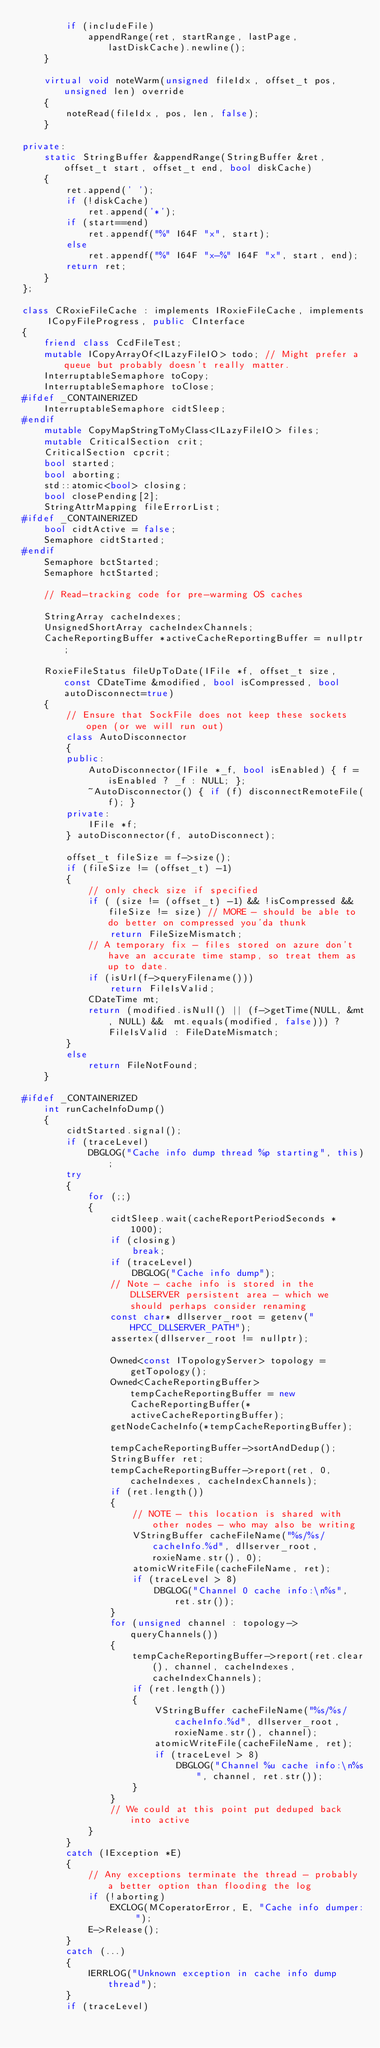<code> <loc_0><loc_0><loc_500><loc_500><_C++_>        if (includeFile)
            appendRange(ret, startRange, lastPage, lastDiskCache).newline();
    }

    virtual void noteWarm(unsigned fileIdx, offset_t pos, unsigned len) override
    {
        noteRead(fileIdx, pos, len, false);
    }

private:
    static StringBuffer &appendRange(StringBuffer &ret, offset_t start, offset_t end, bool diskCache)
    {
        ret.append(' ');
        if (!diskCache)
            ret.append('*');
        if (start==end)
            ret.appendf("%" I64F "x", start);
        else
            ret.appendf("%" I64F "x-%" I64F "x", start, end);
        return ret;
    }
};

class CRoxieFileCache : implements IRoxieFileCache, implements ICopyFileProgress, public CInterface
{
    friend class CcdFileTest;
    mutable ICopyArrayOf<ILazyFileIO> todo; // Might prefer a queue but probably doesn't really matter.
    InterruptableSemaphore toCopy;
    InterruptableSemaphore toClose;
#ifdef _CONTAINERIZED
    InterruptableSemaphore cidtSleep;
#endif
    mutable CopyMapStringToMyClass<ILazyFileIO> files;
    mutable CriticalSection crit;
    CriticalSection cpcrit;
    bool started;
    bool aborting;
    std::atomic<bool> closing;
    bool closePending[2];
    StringAttrMapping fileErrorList;
#ifdef _CONTAINERIZED
    bool cidtActive = false;
    Semaphore cidtStarted;
#endif
    Semaphore bctStarted;
    Semaphore hctStarted;

    // Read-tracking code for pre-warming OS caches

    StringArray cacheIndexes;
    UnsignedShortArray cacheIndexChannels;
    CacheReportingBuffer *activeCacheReportingBuffer = nullptr;

    RoxieFileStatus fileUpToDate(IFile *f, offset_t size, const CDateTime &modified, bool isCompressed, bool autoDisconnect=true)
    {
        // Ensure that SockFile does not keep these sockets open (or we will run out)
        class AutoDisconnector
        {
        public:
            AutoDisconnector(IFile *_f, bool isEnabled) { f = isEnabled ? _f : NULL; };
            ~AutoDisconnector() { if (f) disconnectRemoteFile(f); }
        private:
            IFile *f;
        } autoDisconnector(f, autoDisconnect);

        offset_t fileSize = f->size();
        if (fileSize != (offset_t) -1)
        {
            // only check size if specified
            if ( (size != (offset_t) -1) && !isCompressed && fileSize != size) // MORE - should be able to do better on compressed you'da thunk
                return FileSizeMismatch;
            // A temporary fix - files stored on azure don't have an accurate time stamp, so treat them as up to date.
            if (isUrl(f->queryFilename()))
                return FileIsValid;
            CDateTime mt;
            return (modified.isNull() || (f->getTime(NULL, &mt, NULL) &&  mt.equals(modified, false))) ? FileIsValid : FileDateMismatch;
        }
        else
            return FileNotFound;
    }

#ifdef _CONTAINERIZED
    int runCacheInfoDump()
    {
        cidtStarted.signal();
        if (traceLevel)
            DBGLOG("Cache info dump thread %p starting", this);
        try
        {
            for (;;)
            {
                cidtSleep.wait(cacheReportPeriodSeconds * 1000);
                if (closing)
                    break;
                if (traceLevel)
                    DBGLOG("Cache info dump");
                // Note - cache info is stored in the DLLSERVER persistent area - which we should perhaps consider renaming
                const char* dllserver_root = getenv("HPCC_DLLSERVER_PATH");
                assertex(dllserver_root != nullptr);

                Owned<const ITopologyServer> topology = getTopology();
                Owned<CacheReportingBuffer> tempCacheReportingBuffer = new CacheReportingBuffer(*activeCacheReportingBuffer);
                getNodeCacheInfo(*tempCacheReportingBuffer);

                tempCacheReportingBuffer->sortAndDedup();
                StringBuffer ret;
                tempCacheReportingBuffer->report(ret, 0, cacheIndexes, cacheIndexChannels);
                if (ret.length())
                {
                    // NOTE - this location is shared with other nodes - who may also be writing
                    VStringBuffer cacheFileName("%s/%s/cacheInfo.%d", dllserver_root, roxieName.str(), 0);
                    atomicWriteFile(cacheFileName, ret);
                    if (traceLevel > 8)
                        DBGLOG("Channel 0 cache info:\n%s", ret.str());
                }
                for (unsigned channel : topology->queryChannels())
                {
                    tempCacheReportingBuffer->report(ret.clear(), channel, cacheIndexes, cacheIndexChannels);
                    if (ret.length())
                    {
                        VStringBuffer cacheFileName("%s/%s/cacheInfo.%d", dllserver_root, roxieName.str(), channel);
                        atomicWriteFile(cacheFileName, ret);
                        if (traceLevel > 8)
                            DBGLOG("Channel %u cache info:\n%s", channel, ret.str());
                    }
                }
                // We could at this point put deduped back into active
            }
        }
        catch (IException *E)
        {
            // Any exceptions terminate the thread - probably a better option than flooding the log
            if (!aborting)
                EXCLOG(MCoperatorError, E, "Cache info dumper: ");
            E->Release();
        }
        catch (...)
        {
            IERRLOG("Unknown exception in cache info dump thread");
        }
        if (traceLevel)</code> 